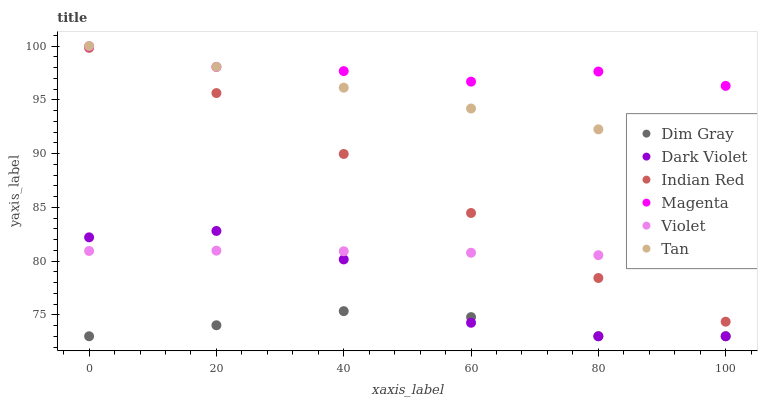Does Dim Gray have the minimum area under the curve?
Answer yes or no. Yes. Does Magenta have the maximum area under the curve?
Answer yes or no. Yes. Does Dark Violet have the minimum area under the curve?
Answer yes or no. No. Does Dark Violet have the maximum area under the curve?
Answer yes or no. No. Is Tan the smoothest?
Answer yes or no. Yes. Is Dark Violet the roughest?
Answer yes or no. Yes. Is Indian Red the smoothest?
Answer yes or no. No. Is Indian Red the roughest?
Answer yes or no. No. Does Dim Gray have the lowest value?
Answer yes or no. Yes. Does Indian Red have the lowest value?
Answer yes or no. No. Does Tan have the highest value?
Answer yes or no. Yes. Does Dark Violet have the highest value?
Answer yes or no. No. Is Indian Red less than Magenta?
Answer yes or no. Yes. Is Indian Red greater than Dim Gray?
Answer yes or no. Yes. Does Dark Violet intersect Dim Gray?
Answer yes or no. Yes. Is Dark Violet less than Dim Gray?
Answer yes or no. No. Is Dark Violet greater than Dim Gray?
Answer yes or no. No. Does Indian Red intersect Magenta?
Answer yes or no. No. 